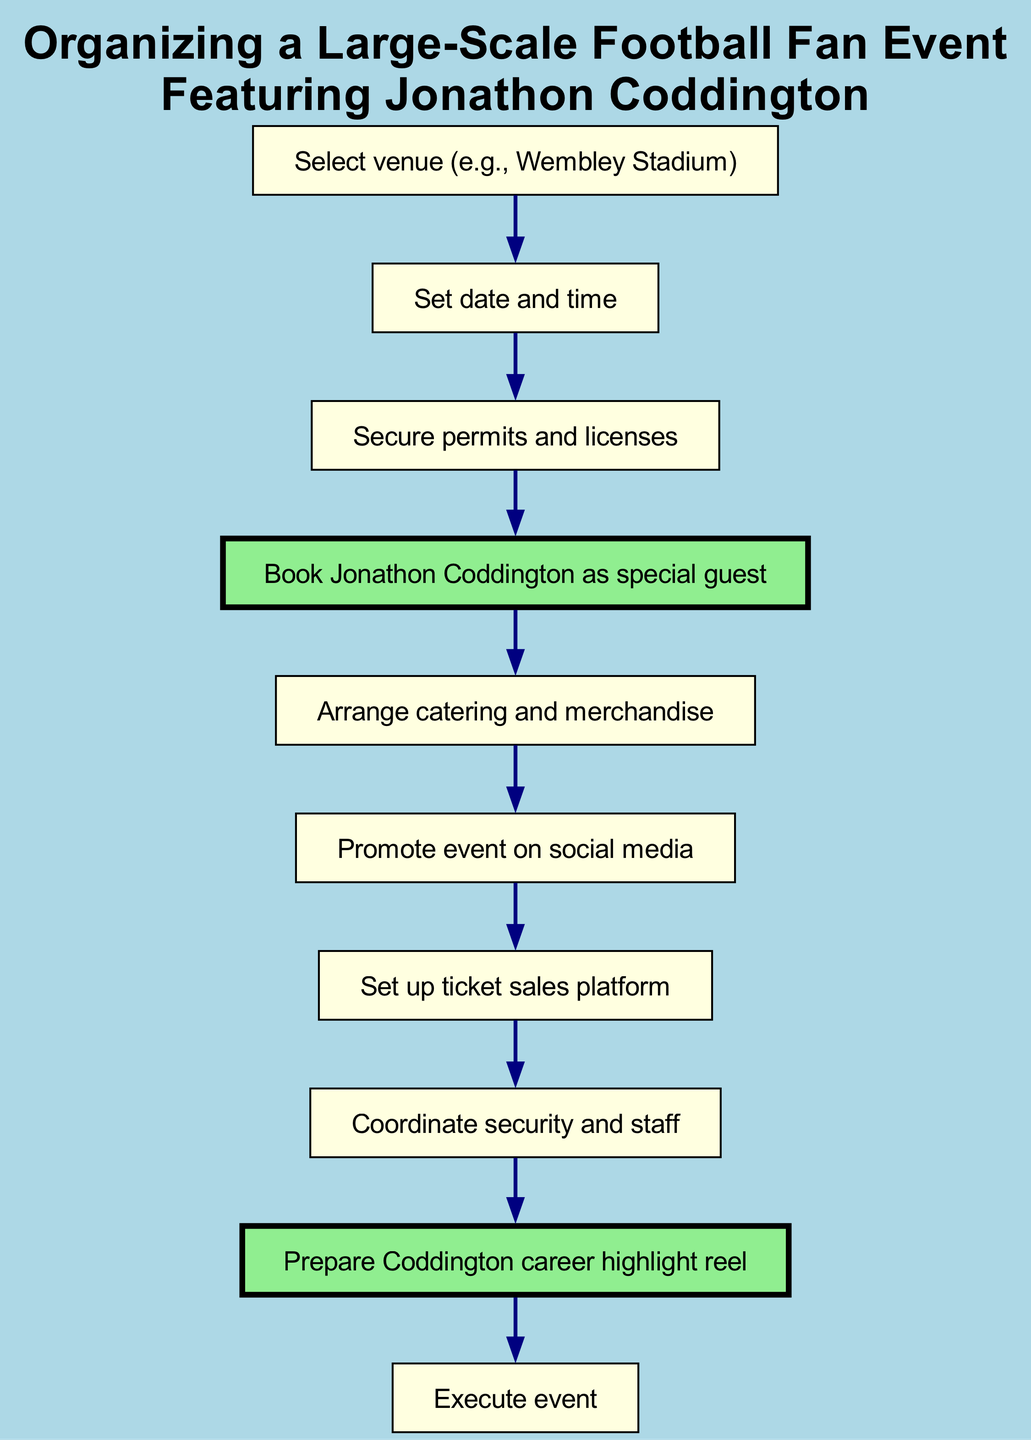What is the first step in organizing the event? The first step in the flow chart is selecting the venue. This is indicated as node one.
Answer: Select venue (e.g., Wembley Stadium) How many total nodes are in the diagram? To find the total number of nodes, I count them in the diagram. There are ten nodes representing different steps.
Answer: 10 What comes after securing permits and licenses? By following the flow from node three to the next node, the step that comes after securing permits and licenses is booking Jonathon Coddington as a special guest.
Answer: Book Jonathon Coddington as special guest Which step involves promoting the event? Promotion takes place after the catering and merchandise arrangement, as seen when following the flow from node five to node six.
Answer: Promote event on social media Name one step directly connected to the preparation of Jonathon Coddington's highlight reel. The step directly connected to the preparation of Jonathon Coddington's highlight reel is coordinating security and staff, which leads to the highlight reel preparation before the execution of the event.
Answer: Coordinate security and staff What are the last three steps in the event organization? The last three steps can be determined by following the flow from the fourth last node. They include preparing the highlight reel, executing the event, and the step before preparing the highlight reel which is coordinating security and staff, making it sequential.
Answer: Prepare Coddington career highlight reel, Execute event Which node is highlighted in green in the diagram? I can observe that node four, which shows booking Jonathon Coddington, and node nine, which indicates preparing his highlight reel, are highlighted in green for significance.
Answer: Book Jonathon Coddington as special guest, Prepare Coddington career highlight reel What is the fourth step in this event organization process? By looking at the numbering in the flow chart, the fourth step is clearly marked as booking Jonathon Coddington as the special guest.
Answer: Book Jonathon Coddington as special guest 